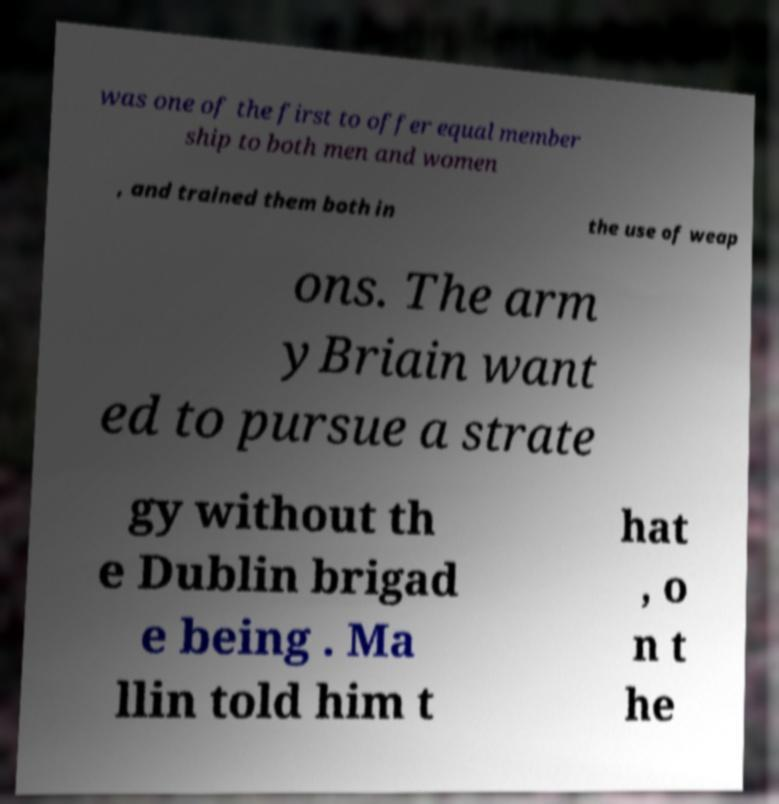Could you extract and type out the text from this image? was one of the first to offer equal member ship to both men and women , and trained them both in the use of weap ons. The arm yBriain want ed to pursue a strate gy without th e Dublin brigad e being . Ma llin told him t hat , o n t he 